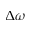Convert formula to latex. <formula><loc_0><loc_0><loc_500><loc_500>\Delta \omega</formula> 